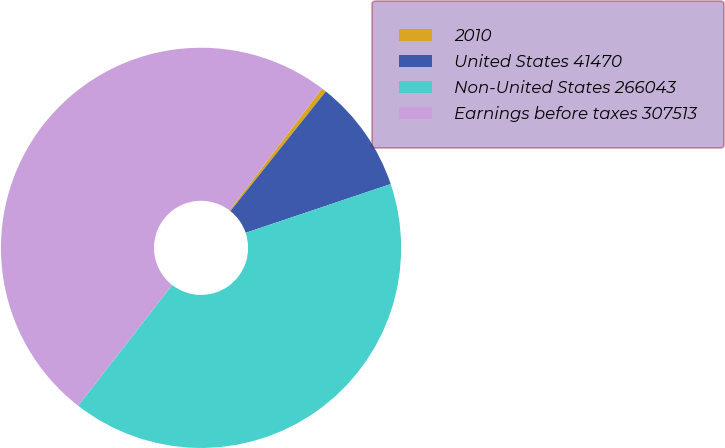Convert chart. <chart><loc_0><loc_0><loc_500><loc_500><pie_chart><fcel>2010<fcel>United States 41470<fcel>Non-United States 266043<fcel>Earnings before taxes 307513<nl><fcel>0.38%<fcel>9.12%<fcel>40.69%<fcel>49.81%<nl></chart> 